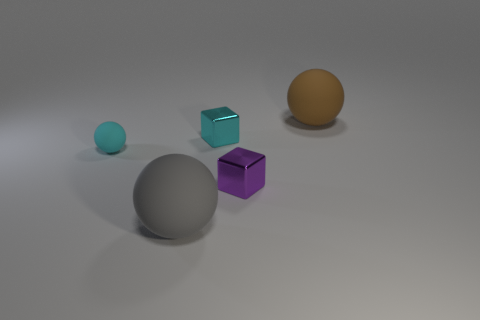The tiny thing that is the same shape as the big gray thing is what color?
Make the answer very short. Cyan. Are there any other things that are the same shape as the brown matte object?
Ensure brevity in your answer.  Yes. How many cubes are either tiny purple things or cyan things?
Provide a succinct answer. 2. What shape is the cyan metallic thing?
Provide a succinct answer. Cube. There is a brown sphere; are there any large rubber spheres right of it?
Make the answer very short. No. Does the gray sphere have the same material as the cube that is in front of the tiny cyan sphere?
Ensure brevity in your answer.  No. There is a large matte object that is behind the large gray ball; does it have the same shape as the purple object?
Provide a succinct answer. No. How many big objects are made of the same material as the large gray ball?
Your answer should be very brief. 1. What number of objects are big balls behind the small matte ball or purple blocks?
Make the answer very short. 2. What size is the cyan matte object?
Give a very brief answer. Small. 